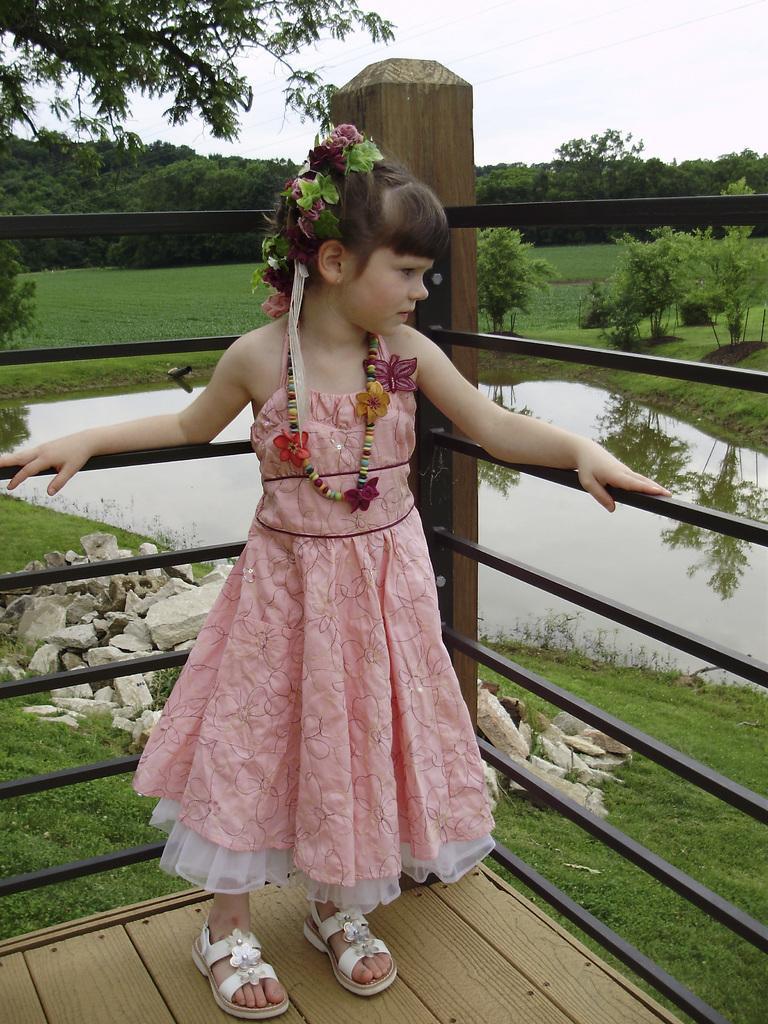Can you describe this image briefly? Here we can see a girl standing on the floor. This is a fence and there are stones. Here we can see water, plants, grass, and trees. In the background there is sky. 